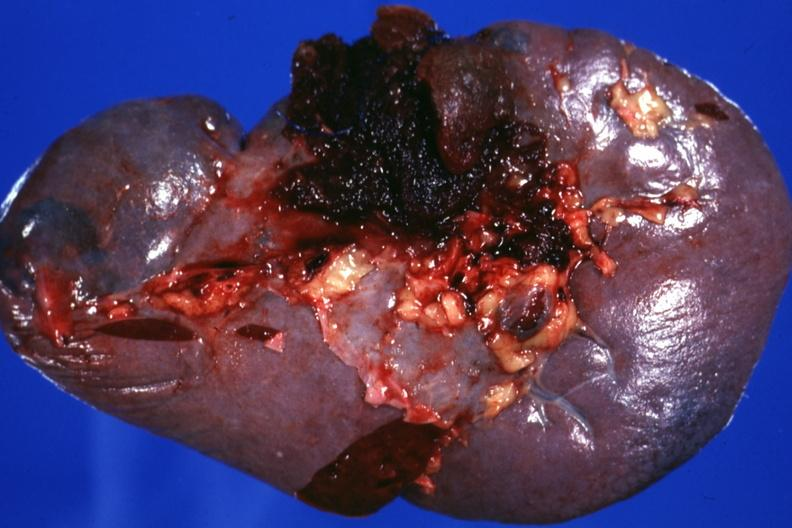s abdomen present?
Answer the question using a single word or phrase. No 